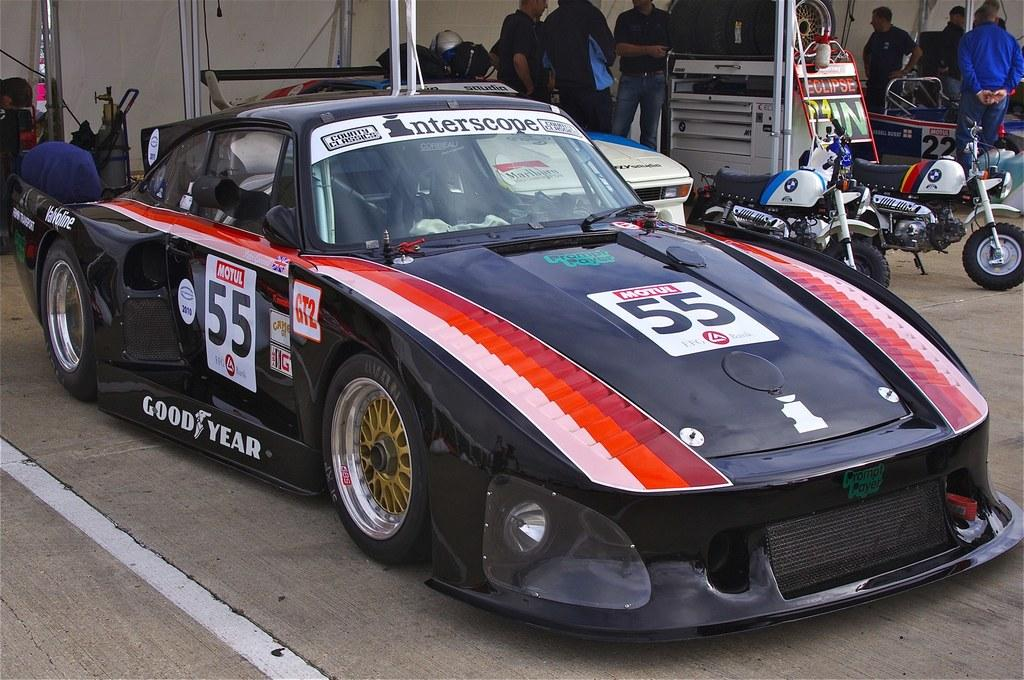What types of objects can be seen in the image? There are vehicles and persons standing in the image. Can you describe the setting of the image? There is a wall in the background of the image. What type of bucket can be seen in the image? There is no bucket present in the image. What effect does the oil have on the vehicles in the image? There is no mention of oil in the image, so its effect cannot be determined. 